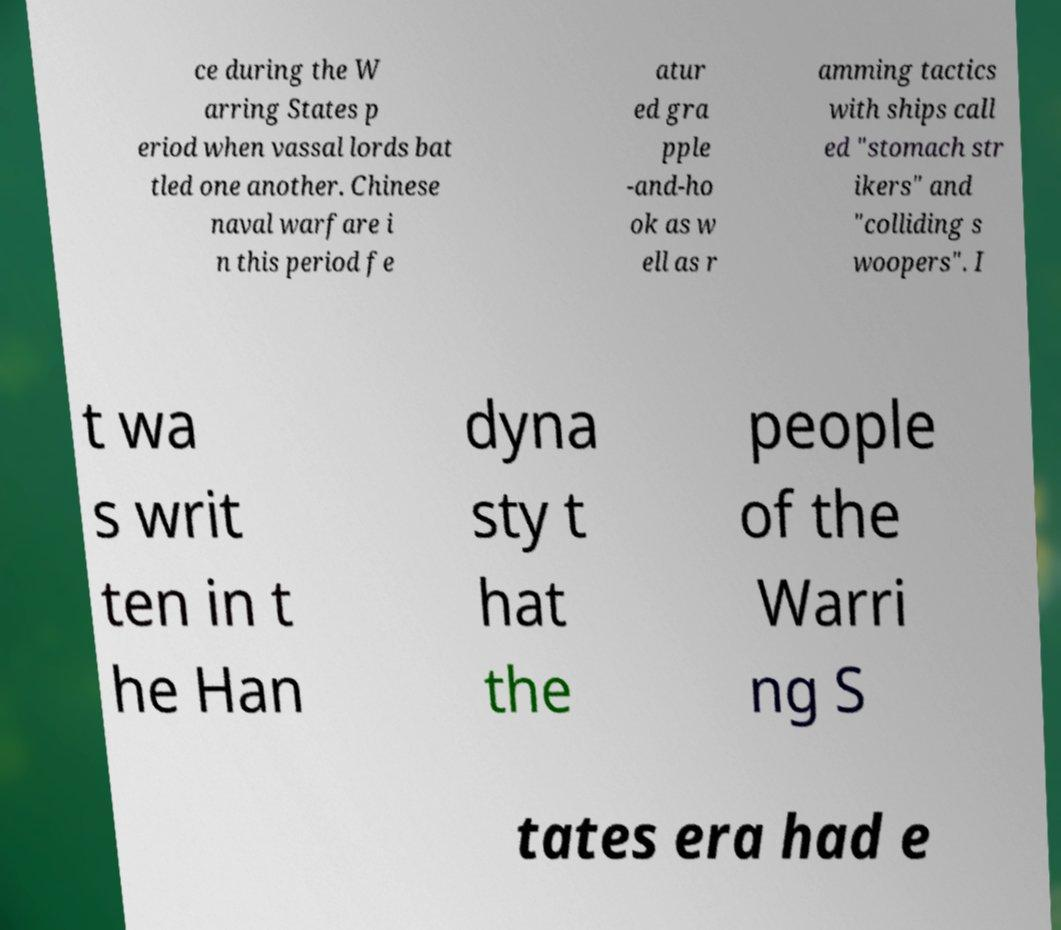Can you accurately transcribe the text from the provided image for me? ce during the W arring States p eriod when vassal lords bat tled one another. Chinese naval warfare i n this period fe atur ed gra pple -and-ho ok as w ell as r amming tactics with ships call ed "stomach str ikers" and "colliding s woopers". I t wa s writ ten in t he Han dyna sty t hat the people of the Warri ng S tates era had e 